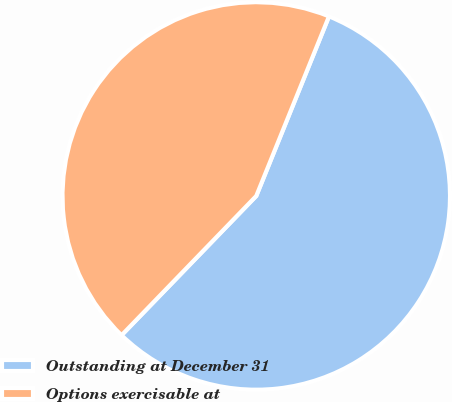Convert chart. <chart><loc_0><loc_0><loc_500><loc_500><pie_chart><fcel>Outstanding at December 31<fcel>Options exercisable at<nl><fcel>56.11%<fcel>43.89%<nl></chart> 